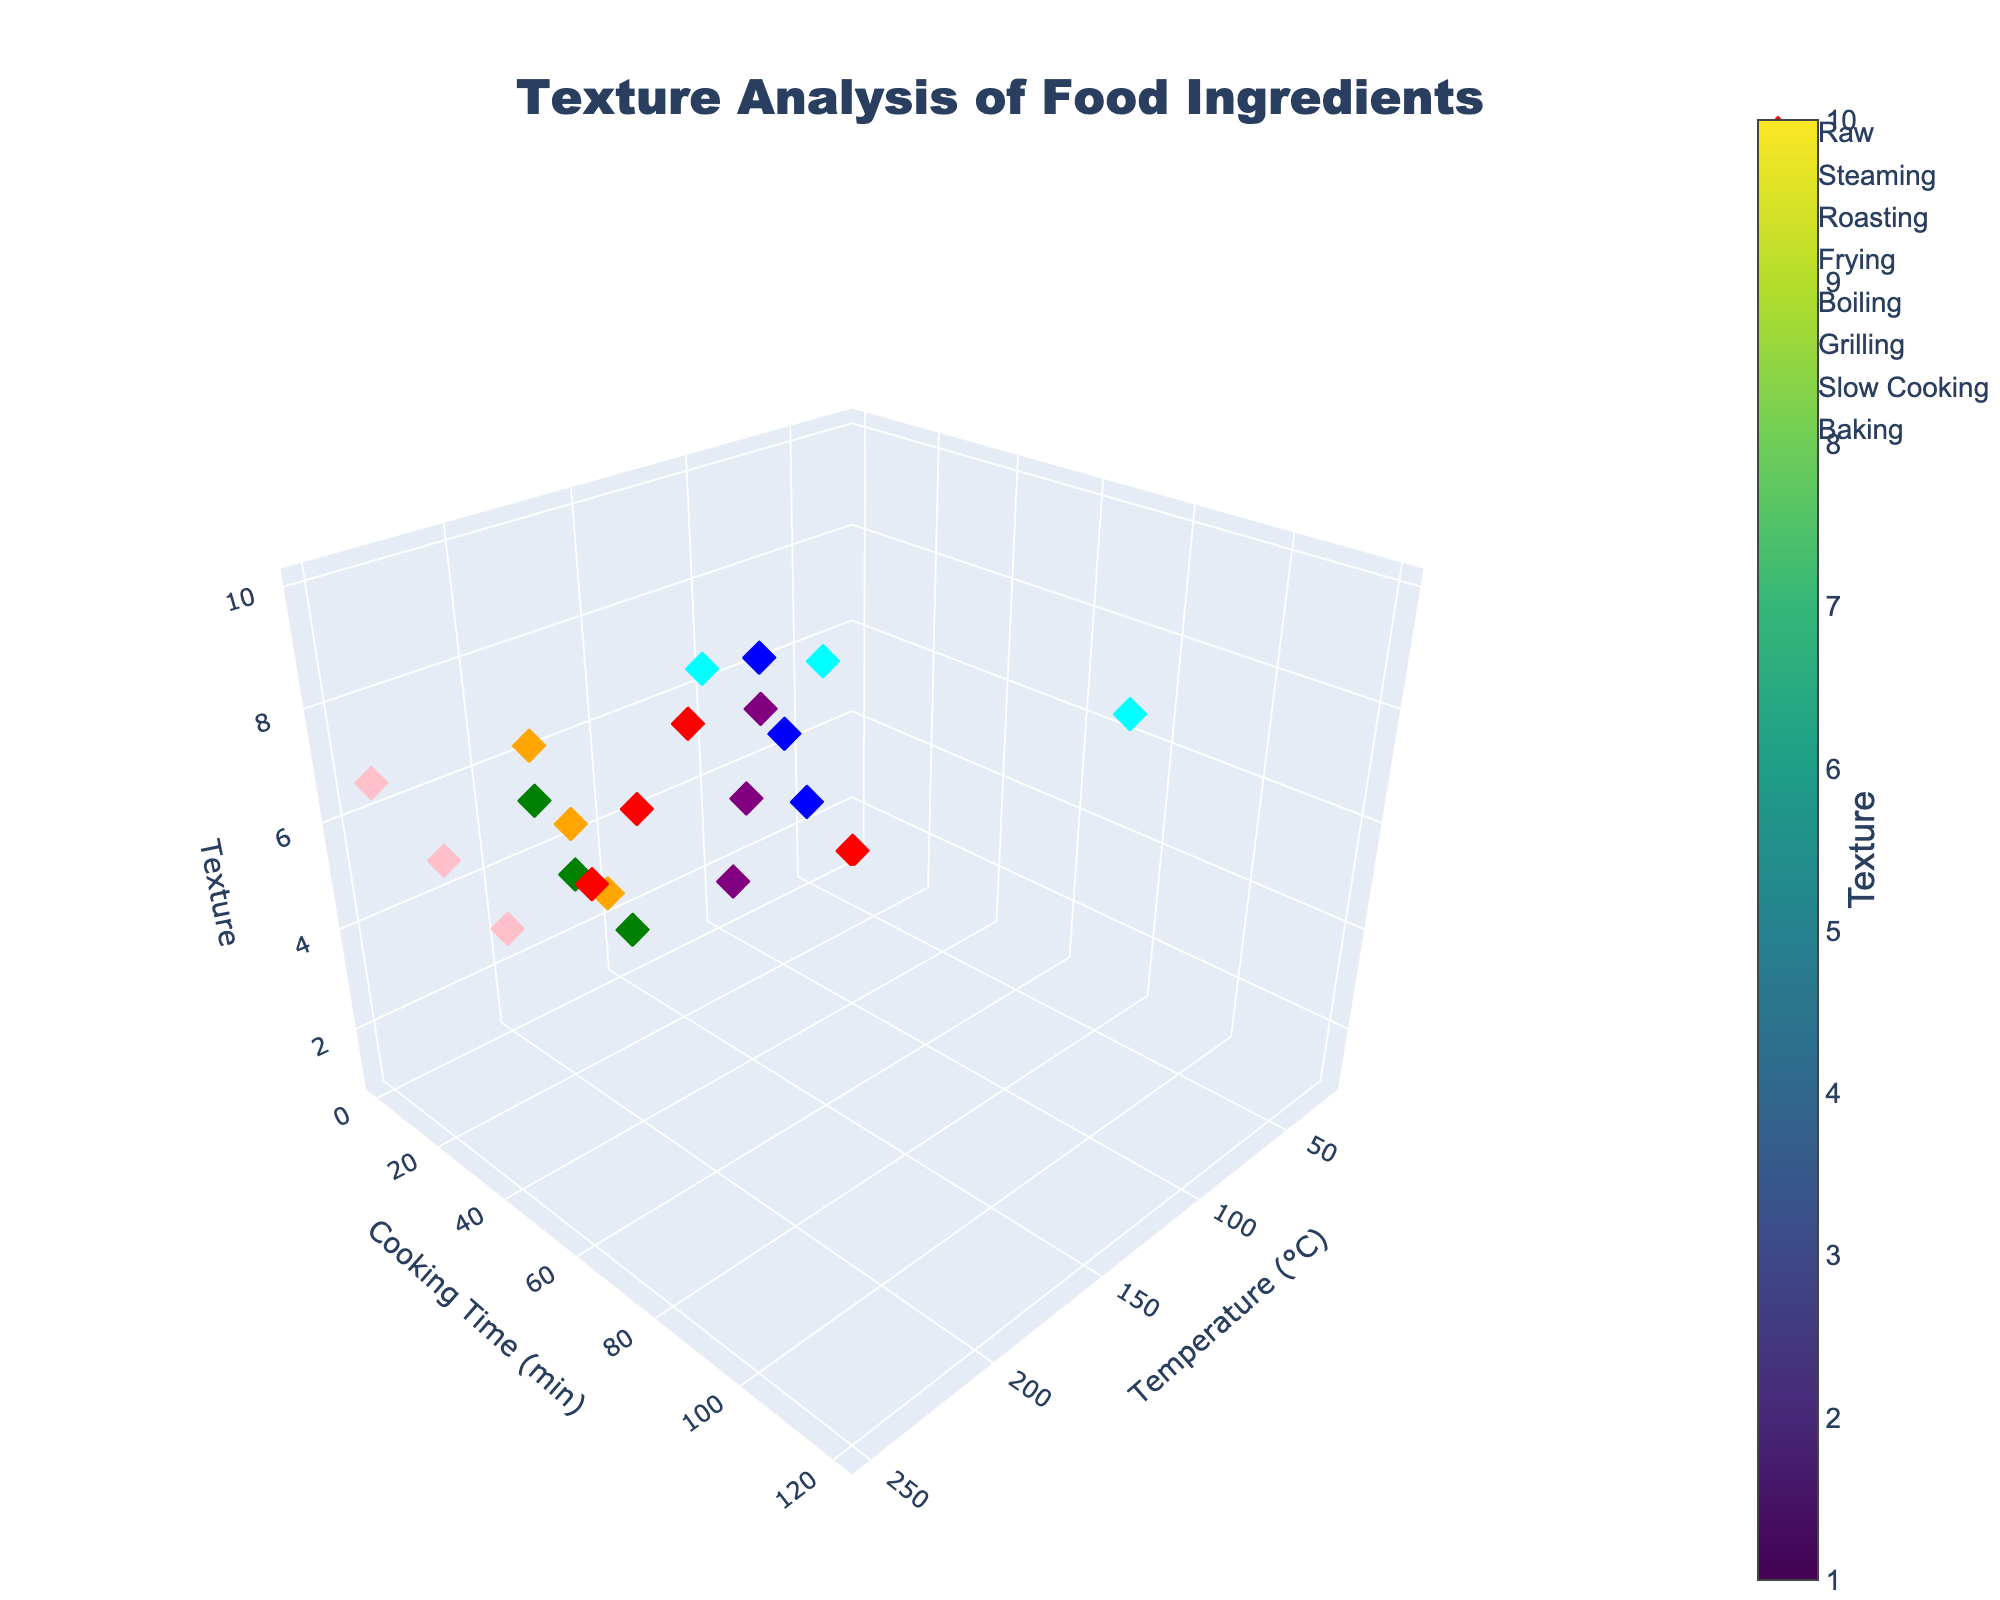What's the title of the figure? The title is usually displayed prominently at the top of the figure and is meant to convey the main subject or insight of the plot.
Answer: Texture Analysis of Food Ingredients What is the range of the 'Texture' axis? To find the range, look at the minimum and maximum values on the 'Texture' axis. In this case, it's given by 'isomin' and 'isomax'.
Answer: 1 to 10 How many cooking techniques are displayed in the figure? The legend lists the unique cooking techniques represented by different colors or symbols.
Answer: 7 Which cooking technique appears to have the highest texture values? By observing the scatter points and their positions along the 'Texture' axis, identify which technique's points reach the highest values.
Answer: Slow Cooking What temperature and cooking time generally result in the smoothest texture? Look at the scatter points that are low on the 'Texture' axis. They represent the smoothest textures. Note their corresponding temperature and cooking time coordinates.
Answer: 25°C and 0 minutes Between Steaming and Roasting, which technique achieves a higher texture at 15 minutes of cooking time? Compare the texture values of the scatter points grouped by cooking technique with a cooking time of 15 minutes.
Answer: Steaming What is the average texture value for Baking? Locate all the scatter points for Baking, sum their 'Texture' values, and divide by the number of points. The Baking points are at textures 4, 6, and 8. Average these values (4+6+8) / 3 = 6.
Answer: 6 Which cooking technique shows the greatest variation in texture? Identify the technique that has the widest spread of texture values from its lowest to highest point.
Answer: Slow Cooking What is the median texture value for Frying? For Frying, sort the texture values (3, 5, 7) and find the middle one. In this case, the three values are already sorted, and the middle one is 5.
Answer: 5 How does the texture change with increasing cooking time for Boiling at 100°C? Observe the trend of texture values for Boiling technique scatter points as cooking time increases.
Answer: It increases 